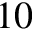<formula> <loc_0><loc_0><loc_500><loc_500>1 0</formula> 